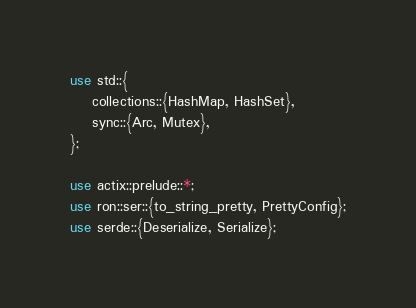<code> <loc_0><loc_0><loc_500><loc_500><_Rust_>use std::{
    collections::{HashMap, HashSet},
    sync::{Arc, Mutex},
};

use actix::prelude::*;
use ron::ser::{to_string_pretty, PrettyConfig};
use serde::{Deserialize, Serialize};</code> 